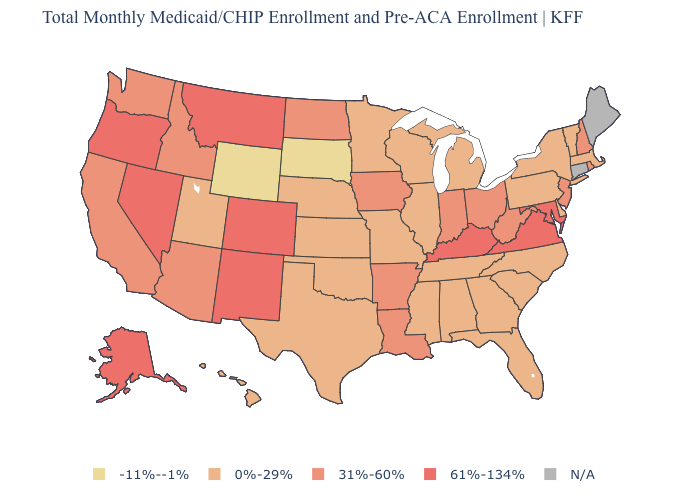What is the highest value in states that border Wisconsin?
Write a very short answer. 31%-60%. What is the value of Arkansas?
Short answer required. 31%-60%. What is the value of Wisconsin?
Keep it brief. 0%-29%. Name the states that have a value in the range 0%-29%?
Concise answer only. Alabama, Delaware, Florida, Georgia, Hawaii, Illinois, Kansas, Massachusetts, Michigan, Minnesota, Mississippi, Missouri, Nebraska, New York, North Carolina, Oklahoma, Pennsylvania, South Carolina, Tennessee, Texas, Utah, Vermont, Wisconsin. What is the value of North Carolina?
Answer briefly. 0%-29%. Name the states that have a value in the range N/A?
Be succinct. Connecticut, Maine. What is the value of Georgia?
Answer briefly. 0%-29%. Which states have the lowest value in the USA?
Quick response, please. South Dakota, Wyoming. Which states have the lowest value in the MidWest?
Short answer required. South Dakota. How many symbols are there in the legend?
Answer briefly. 5. What is the value of Wisconsin?
Concise answer only. 0%-29%. What is the value of Washington?
Answer briefly. 31%-60%. Name the states that have a value in the range N/A?
Write a very short answer. Connecticut, Maine. 